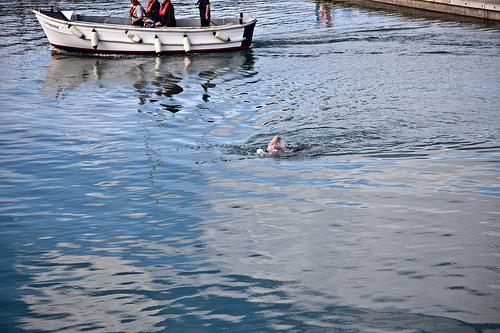Question: who is in charge of a boat?
Choices:
A. Captain.
B. Owner.
C. Man.
D. Woman.
Answer with the letter. Answer: A Question: how many people are in the boat?
Choices:
A. Three.
B. Five.
C. Four.
D. Six.
Answer with the letter. Answer: C Question: where is the swimmer?
Choices:
A. To the left.
B. To the right.
C. Water.
D. In the background.
Answer with the letter. Answer: C Question: what color are the life vests on the people in the boat?
Choices:
A. Red.
B. Orange.
C. Yellow.
D. Green.
Answer with the letter. Answer: B 